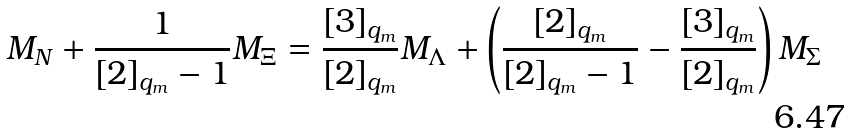<formula> <loc_0><loc_0><loc_500><loc_500>M _ { N } + \frac { 1 } { [ 2 ] _ { q _ { m } } - 1 } M _ { \Xi } = \frac { [ 3 ] _ { q _ { m } } } { [ 2 ] _ { q _ { m } } } M _ { \Lambda } + \left ( \frac { [ 2 ] _ { q _ { m } } } { [ 2 ] _ { q _ { m } } - 1 } - \frac { [ 3 ] _ { q _ { m } } } { [ 2 ] _ { q _ { m } } } \right ) M _ { \Sigma }</formula> 